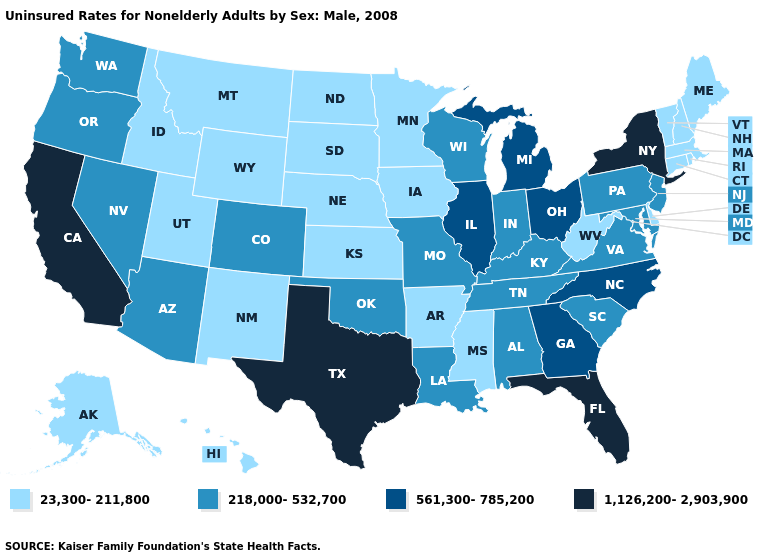Does the first symbol in the legend represent the smallest category?
Write a very short answer. Yes. Does Idaho have a higher value than Oklahoma?
Answer briefly. No. Does the first symbol in the legend represent the smallest category?
Write a very short answer. Yes. Does Wisconsin have the lowest value in the MidWest?
Give a very brief answer. No. Is the legend a continuous bar?
Quick response, please. No. What is the value of Montana?
Quick response, please. 23,300-211,800. What is the value of Iowa?
Concise answer only. 23,300-211,800. Does Arizona have a lower value than Illinois?
Be succinct. Yes. Name the states that have a value in the range 23,300-211,800?
Write a very short answer. Alaska, Arkansas, Connecticut, Delaware, Hawaii, Idaho, Iowa, Kansas, Maine, Massachusetts, Minnesota, Mississippi, Montana, Nebraska, New Hampshire, New Mexico, North Dakota, Rhode Island, South Dakota, Utah, Vermont, West Virginia, Wyoming. What is the value of New Jersey?
Quick response, please. 218,000-532,700. Among the states that border Arizona , which have the highest value?
Keep it brief. California. Does the first symbol in the legend represent the smallest category?
Be succinct. Yes. Name the states that have a value in the range 1,126,200-2,903,900?
Write a very short answer. California, Florida, New York, Texas. Which states have the lowest value in the West?
Concise answer only. Alaska, Hawaii, Idaho, Montana, New Mexico, Utah, Wyoming. What is the highest value in the MidWest ?
Quick response, please. 561,300-785,200. 